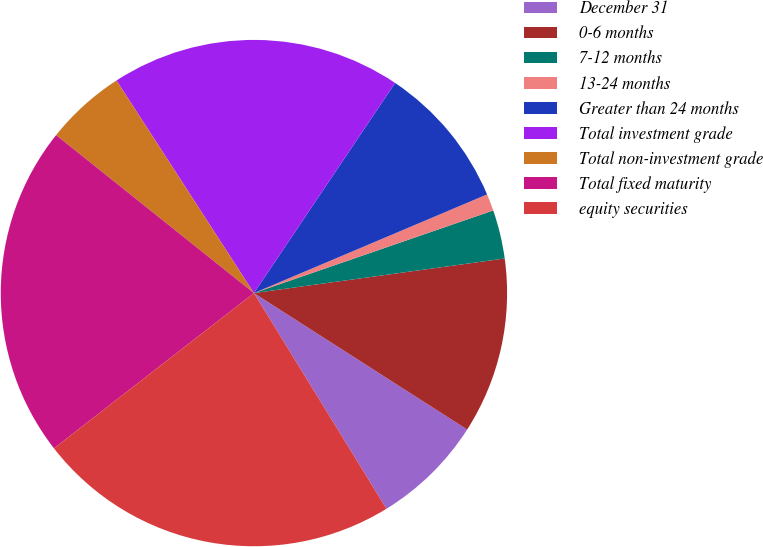Convert chart to OTSL. <chart><loc_0><loc_0><loc_500><loc_500><pie_chart><fcel>December 31<fcel>0-6 months<fcel>7-12 months<fcel>13-24 months<fcel>Greater than 24 months<fcel>Total investment grade<fcel>Total non-investment grade<fcel>Total fixed maturity<fcel>equity securities<nl><fcel>7.17%<fcel>11.24%<fcel>3.11%<fcel>1.08%<fcel>9.21%<fcel>18.55%<fcel>5.14%<fcel>21.23%<fcel>23.26%<nl></chart> 